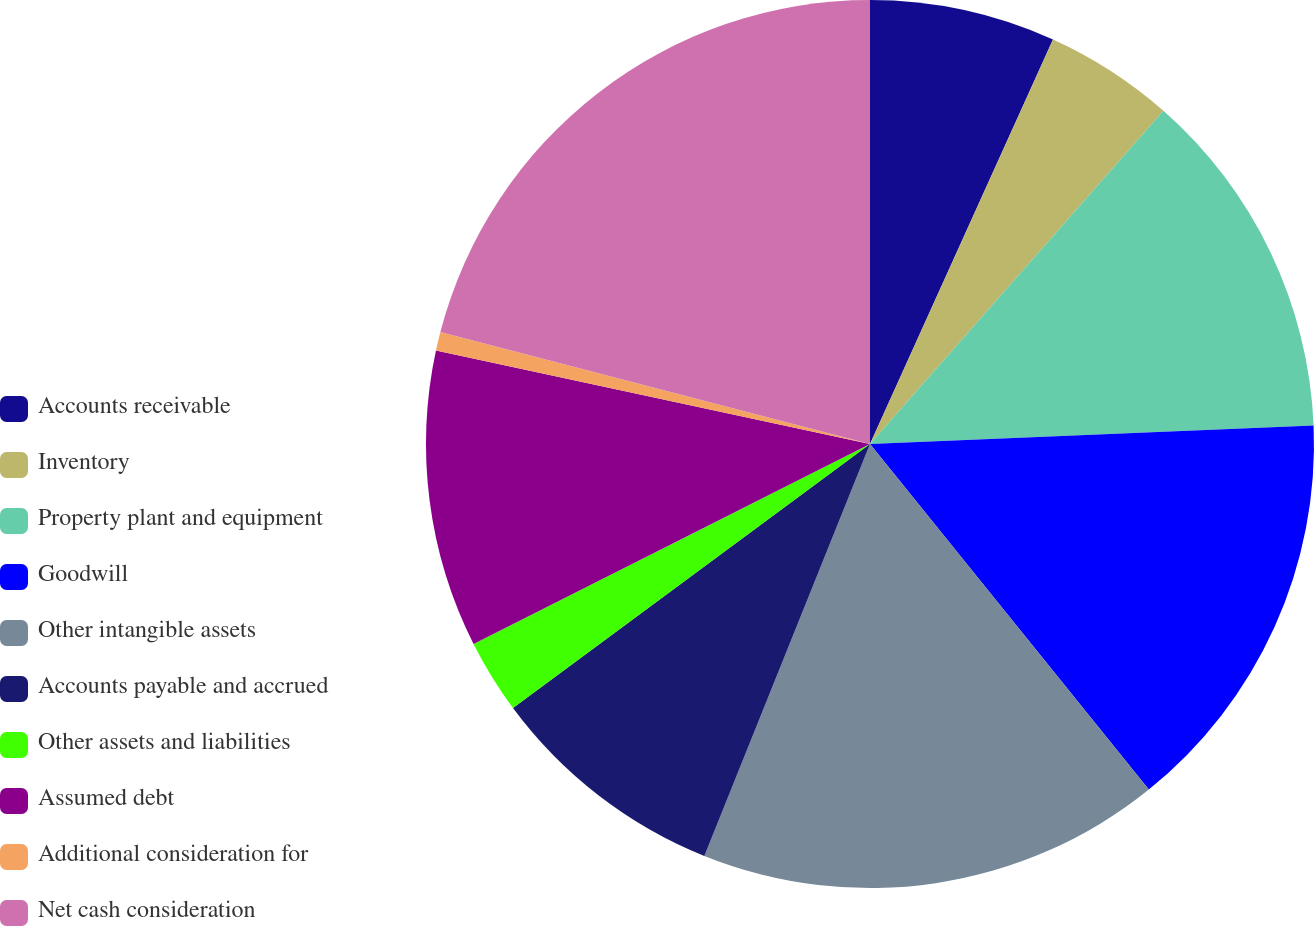Convert chart to OTSL. <chart><loc_0><loc_0><loc_500><loc_500><pie_chart><fcel>Accounts receivable<fcel>Inventory<fcel>Property plant and equipment<fcel>Goodwill<fcel>Other intangible assets<fcel>Accounts payable and accrued<fcel>Other assets and liabilities<fcel>Assumed debt<fcel>Additional consideration for<fcel>Net cash consideration<nl><fcel>6.76%<fcel>4.73%<fcel>12.84%<fcel>14.86%<fcel>16.89%<fcel>8.78%<fcel>2.7%<fcel>10.81%<fcel>0.68%<fcel>20.94%<nl></chart> 